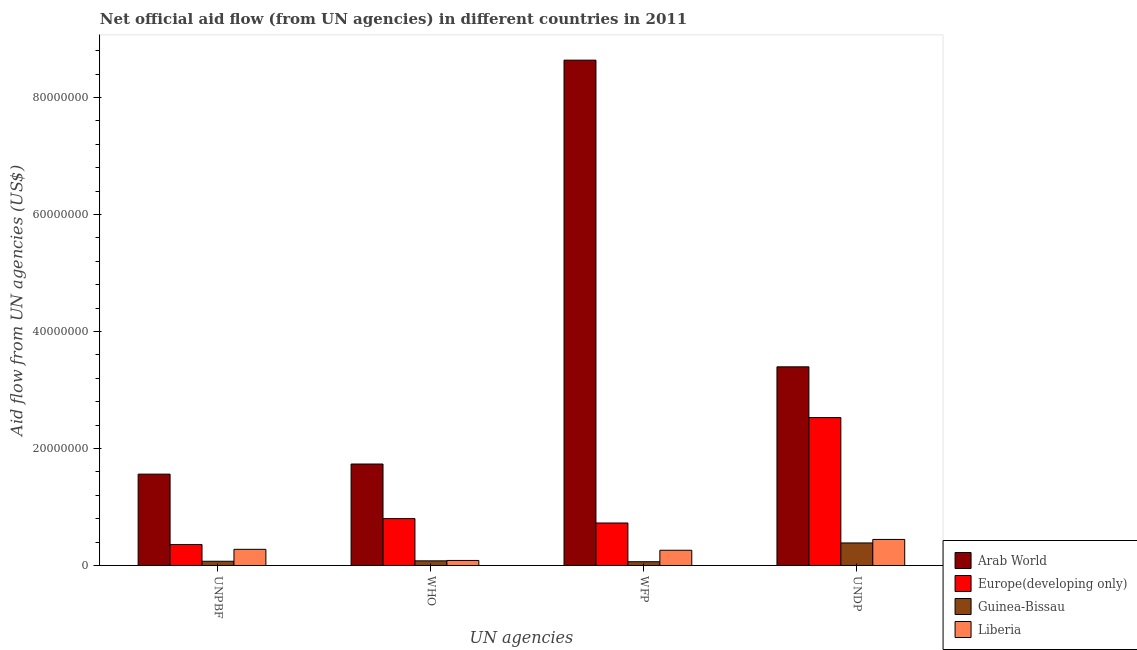How many bars are there on the 4th tick from the right?
Provide a short and direct response. 4. What is the label of the 1st group of bars from the left?
Keep it short and to the point. UNPBF. What is the amount of aid given by unpbf in Guinea-Bissau?
Your response must be concise. 7.20e+05. Across all countries, what is the maximum amount of aid given by who?
Your response must be concise. 1.73e+07. Across all countries, what is the minimum amount of aid given by unpbf?
Keep it short and to the point. 7.20e+05. In which country was the amount of aid given by undp maximum?
Your response must be concise. Arab World. In which country was the amount of aid given by undp minimum?
Provide a short and direct response. Guinea-Bissau. What is the total amount of aid given by undp in the graph?
Provide a succinct answer. 6.75e+07. What is the difference between the amount of aid given by undp in Liberia and that in Europe(developing only)?
Give a very brief answer. -2.08e+07. What is the difference between the amount of aid given by wfp in Europe(developing only) and the amount of aid given by who in Guinea-Bissau?
Your response must be concise. 6.47e+06. What is the average amount of aid given by unpbf per country?
Keep it short and to the point. 5.67e+06. What is the difference between the amount of aid given by wfp and amount of aid given by unpbf in Guinea-Bissau?
Provide a short and direct response. -8.00e+04. What is the ratio of the amount of aid given by undp in Liberia to that in Arab World?
Your answer should be compact. 0.13. What is the difference between the highest and the second highest amount of aid given by undp?
Give a very brief answer. 8.67e+06. What is the difference between the highest and the lowest amount of aid given by who?
Ensure brevity in your answer.  1.66e+07. Is it the case that in every country, the sum of the amount of aid given by unpbf and amount of aid given by who is greater than the sum of amount of aid given by wfp and amount of aid given by undp?
Offer a terse response. No. What does the 2nd bar from the left in UNDP represents?
Keep it short and to the point. Europe(developing only). What does the 4th bar from the right in UNPBF represents?
Your answer should be very brief. Arab World. Are all the bars in the graph horizontal?
Provide a short and direct response. No. How many countries are there in the graph?
Your answer should be very brief. 4. Are the values on the major ticks of Y-axis written in scientific E-notation?
Keep it short and to the point. No. Where does the legend appear in the graph?
Offer a very short reply. Bottom right. How are the legend labels stacked?
Keep it short and to the point. Vertical. What is the title of the graph?
Your answer should be compact. Net official aid flow (from UN agencies) in different countries in 2011. Does "Seychelles" appear as one of the legend labels in the graph?
Provide a succinct answer. No. What is the label or title of the X-axis?
Offer a very short reply. UN agencies. What is the label or title of the Y-axis?
Keep it short and to the point. Aid flow from UN agencies (US$). What is the Aid flow from UN agencies (US$) of Arab World in UNPBF?
Provide a short and direct response. 1.56e+07. What is the Aid flow from UN agencies (US$) of Europe(developing only) in UNPBF?
Provide a short and direct response. 3.58e+06. What is the Aid flow from UN agencies (US$) in Guinea-Bissau in UNPBF?
Give a very brief answer. 7.20e+05. What is the Aid flow from UN agencies (US$) in Liberia in UNPBF?
Offer a terse response. 2.76e+06. What is the Aid flow from UN agencies (US$) of Arab World in WHO?
Ensure brevity in your answer.  1.73e+07. What is the Aid flow from UN agencies (US$) of Europe(developing only) in WHO?
Offer a terse response. 8.01e+06. What is the Aid flow from UN agencies (US$) of Guinea-Bissau in WHO?
Offer a very short reply. 7.90e+05. What is the Aid flow from UN agencies (US$) of Liberia in WHO?
Provide a succinct answer. 8.60e+05. What is the Aid flow from UN agencies (US$) of Arab World in WFP?
Make the answer very short. 8.64e+07. What is the Aid flow from UN agencies (US$) in Europe(developing only) in WFP?
Ensure brevity in your answer.  7.26e+06. What is the Aid flow from UN agencies (US$) in Guinea-Bissau in WFP?
Make the answer very short. 6.40e+05. What is the Aid flow from UN agencies (US$) in Liberia in WFP?
Provide a succinct answer. 2.60e+06. What is the Aid flow from UN agencies (US$) of Arab World in UNDP?
Your answer should be compact. 3.40e+07. What is the Aid flow from UN agencies (US$) of Europe(developing only) in UNDP?
Provide a short and direct response. 2.53e+07. What is the Aid flow from UN agencies (US$) of Guinea-Bissau in UNDP?
Keep it short and to the point. 3.85e+06. What is the Aid flow from UN agencies (US$) in Liberia in UNDP?
Your response must be concise. 4.45e+06. Across all UN agencies, what is the maximum Aid flow from UN agencies (US$) of Arab World?
Provide a short and direct response. 8.64e+07. Across all UN agencies, what is the maximum Aid flow from UN agencies (US$) in Europe(developing only)?
Your answer should be very brief. 2.53e+07. Across all UN agencies, what is the maximum Aid flow from UN agencies (US$) in Guinea-Bissau?
Ensure brevity in your answer.  3.85e+06. Across all UN agencies, what is the maximum Aid flow from UN agencies (US$) in Liberia?
Give a very brief answer. 4.45e+06. Across all UN agencies, what is the minimum Aid flow from UN agencies (US$) in Arab World?
Your answer should be compact. 1.56e+07. Across all UN agencies, what is the minimum Aid flow from UN agencies (US$) in Europe(developing only)?
Keep it short and to the point. 3.58e+06. Across all UN agencies, what is the minimum Aid flow from UN agencies (US$) of Guinea-Bissau?
Your answer should be very brief. 6.40e+05. Across all UN agencies, what is the minimum Aid flow from UN agencies (US$) in Liberia?
Offer a terse response. 8.60e+05. What is the total Aid flow from UN agencies (US$) of Arab World in the graph?
Offer a terse response. 1.53e+08. What is the total Aid flow from UN agencies (US$) in Europe(developing only) in the graph?
Your answer should be very brief. 4.41e+07. What is the total Aid flow from UN agencies (US$) of Liberia in the graph?
Your response must be concise. 1.07e+07. What is the difference between the Aid flow from UN agencies (US$) of Arab World in UNPBF and that in WHO?
Give a very brief answer. -1.73e+06. What is the difference between the Aid flow from UN agencies (US$) in Europe(developing only) in UNPBF and that in WHO?
Your answer should be compact. -4.43e+06. What is the difference between the Aid flow from UN agencies (US$) of Guinea-Bissau in UNPBF and that in WHO?
Offer a terse response. -7.00e+04. What is the difference between the Aid flow from UN agencies (US$) of Liberia in UNPBF and that in WHO?
Give a very brief answer. 1.90e+06. What is the difference between the Aid flow from UN agencies (US$) in Arab World in UNPBF and that in WFP?
Provide a short and direct response. -7.08e+07. What is the difference between the Aid flow from UN agencies (US$) of Europe(developing only) in UNPBF and that in WFP?
Keep it short and to the point. -3.68e+06. What is the difference between the Aid flow from UN agencies (US$) in Guinea-Bissau in UNPBF and that in WFP?
Offer a very short reply. 8.00e+04. What is the difference between the Aid flow from UN agencies (US$) of Arab World in UNPBF and that in UNDP?
Provide a succinct answer. -1.83e+07. What is the difference between the Aid flow from UN agencies (US$) of Europe(developing only) in UNPBF and that in UNDP?
Keep it short and to the point. -2.17e+07. What is the difference between the Aid flow from UN agencies (US$) in Guinea-Bissau in UNPBF and that in UNDP?
Offer a terse response. -3.13e+06. What is the difference between the Aid flow from UN agencies (US$) in Liberia in UNPBF and that in UNDP?
Your answer should be very brief. -1.69e+06. What is the difference between the Aid flow from UN agencies (US$) in Arab World in WHO and that in WFP?
Offer a very short reply. -6.90e+07. What is the difference between the Aid flow from UN agencies (US$) of Europe(developing only) in WHO and that in WFP?
Provide a short and direct response. 7.50e+05. What is the difference between the Aid flow from UN agencies (US$) in Guinea-Bissau in WHO and that in WFP?
Provide a succinct answer. 1.50e+05. What is the difference between the Aid flow from UN agencies (US$) of Liberia in WHO and that in WFP?
Keep it short and to the point. -1.74e+06. What is the difference between the Aid flow from UN agencies (US$) in Arab World in WHO and that in UNDP?
Provide a short and direct response. -1.66e+07. What is the difference between the Aid flow from UN agencies (US$) in Europe(developing only) in WHO and that in UNDP?
Your response must be concise. -1.73e+07. What is the difference between the Aid flow from UN agencies (US$) in Guinea-Bissau in WHO and that in UNDP?
Your answer should be compact. -3.06e+06. What is the difference between the Aid flow from UN agencies (US$) in Liberia in WHO and that in UNDP?
Your answer should be compact. -3.59e+06. What is the difference between the Aid flow from UN agencies (US$) in Arab World in WFP and that in UNDP?
Your answer should be very brief. 5.24e+07. What is the difference between the Aid flow from UN agencies (US$) of Europe(developing only) in WFP and that in UNDP?
Your response must be concise. -1.80e+07. What is the difference between the Aid flow from UN agencies (US$) in Guinea-Bissau in WFP and that in UNDP?
Provide a succinct answer. -3.21e+06. What is the difference between the Aid flow from UN agencies (US$) of Liberia in WFP and that in UNDP?
Give a very brief answer. -1.85e+06. What is the difference between the Aid flow from UN agencies (US$) in Arab World in UNPBF and the Aid flow from UN agencies (US$) in Europe(developing only) in WHO?
Ensure brevity in your answer.  7.60e+06. What is the difference between the Aid flow from UN agencies (US$) in Arab World in UNPBF and the Aid flow from UN agencies (US$) in Guinea-Bissau in WHO?
Your answer should be compact. 1.48e+07. What is the difference between the Aid flow from UN agencies (US$) in Arab World in UNPBF and the Aid flow from UN agencies (US$) in Liberia in WHO?
Provide a short and direct response. 1.48e+07. What is the difference between the Aid flow from UN agencies (US$) in Europe(developing only) in UNPBF and the Aid flow from UN agencies (US$) in Guinea-Bissau in WHO?
Give a very brief answer. 2.79e+06. What is the difference between the Aid flow from UN agencies (US$) in Europe(developing only) in UNPBF and the Aid flow from UN agencies (US$) in Liberia in WHO?
Your answer should be very brief. 2.72e+06. What is the difference between the Aid flow from UN agencies (US$) in Guinea-Bissau in UNPBF and the Aid flow from UN agencies (US$) in Liberia in WHO?
Ensure brevity in your answer.  -1.40e+05. What is the difference between the Aid flow from UN agencies (US$) in Arab World in UNPBF and the Aid flow from UN agencies (US$) in Europe(developing only) in WFP?
Provide a succinct answer. 8.35e+06. What is the difference between the Aid flow from UN agencies (US$) in Arab World in UNPBF and the Aid flow from UN agencies (US$) in Guinea-Bissau in WFP?
Your answer should be very brief. 1.50e+07. What is the difference between the Aid flow from UN agencies (US$) in Arab World in UNPBF and the Aid flow from UN agencies (US$) in Liberia in WFP?
Provide a short and direct response. 1.30e+07. What is the difference between the Aid flow from UN agencies (US$) of Europe(developing only) in UNPBF and the Aid flow from UN agencies (US$) of Guinea-Bissau in WFP?
Provide a succinct answer. 2.94e+06. What is the difference between the Aid flow from UN agencies (US$) of Europe(developing only) in UNPBF and the Aid flow from UN agencies (US$) of Liberia in WFP?
Give a very brief answer. 9.80e+05. What is the difference between the Aid flow from UN agencies (US$) of Guinea-Bissau in UNPBF and the Aid flow from UN agencies (US$) of Liberia in WFP?
Ensure brevity in your answer.  -1.88e+06. What is the difference between the Aid flow from UN agencies (US$) of Arab World in UNPBF and the Aid flow from UN agencies (US$) of Europe(developing only) in UNDP?
Provide a succinct answer. -9.67e+06. What is the difference between the Aid flow from UN agencies (US$) of Arab World in UNPBF and the Aid flow from UN agencies (US$) of Guinea-Bissau in UNDP?
Provide a succinct answer. 1.18e+07. What is the difference between the Aid flow from UN agencies (US$) in Arab World in UNPBF and the Aid flow from UN agencies (US$) in Liberia in UNDP?
Make the answer very short. 1.12e+07. What is the difference between the Aid flow from UN agencies (US$) in Europe(developing only) in UNPBF and the Aid flow from UN agencies (US$) in Liberia in UNDP?
Ensure brevity in your answer.  -8.70e+05. What is the difference between the Aid flow from UN agencies (US$) of Guinea-Bissau in UNPBF and the Aid flow from UN agencies (US$) of Liberia in UNDP?
Give a very brief answer. -3.73e+06. What is the difference between the Aid flow from UN agencies (US$) of Arab World in WHO and the Aid flow from UN agencies (US$) of Europe(developing only) in WFP?
Ensure brevity in your answer.  1.01e+07. What is the difference between the Aid flow from UN agencies (US$) in Arab World in WHO and the Aid flow from UN agencies (US$) in Guinea-Bissau in WFP?
Offer a very short reply. 1.67e+07. What is the difference between the Aid flow from UN agencies (US$) of Arab World in WHO and the Aid flow from UN agencies (US$) of Liberia in WFP?
Your answer should be compact. 1.47e+07. What is the difference between the Aid flow from UN agencies (US$) of Europe(developing only) in WHO and the Aid flow from UN agencies (US$) of Guinea-Bissau in WFP?
Offer a terse response. 7.37e+06. What is the difference between the Aid flow from UN agencies (US$) of Europe(developing only) in WHO and the Aid flow from UN agencies (US$) of Liberia in WFP?
Ensure brevity in your answer.  5.41e+06. What is the difference between the Aid flow from UN agencies (US$) in Guinea-Bissau in WHO and the Aid flow from UN agencies (US$) in Liberia in WFP?
Keep it short and to the point. -1.81e+06. What is the difference between the Aid flow from UN agencies (US$) in Arab World in WHO and the Aid flow from UN agencies (US$) in Europe(developing only) in UNDP?
Make the answer very short. -7.94e+06. What is the difference between the Aid flow from UN agencies (US$) in Arab World in WHO and the Aid flow from UN agencies (US$) in Guinea-Bissau in UNDP?
Offer a very short reply. 1.35e+07. What is the difference between the Aid flow from UN agencies (US$) of Arab World in WHO and the Aid flow from UN agencies (US$) of Liberia in UNDP?
Provide a short and direct response. 1.29e+07. What is the difference between the Aid flow from UN agencies (US$) of Europe(developing only) in WHO and the Aid flow from UN agencies (US$) of Guinea-Bissau in UNDP?
Give a very brief answer. 4.16e+06. What is the difference between the Aid flow from UN agencies (US$) of Europe(developing only) in WHO and the Aid flow from UN agencies (US$) of Liberia in UNDP?
Provide a succinct answer. 3.56e+06. What is the difference between the Aid flow from UN agencies (US$) of Guinea-Bissau in WHO and the Aid flow from UN agencies (US$) of Liberia in UNDP?
Offer a terse response. -3.66e+06. What is the difference between the Aid flow from UN agencies (US$) in Arab World in WFP and the Aid flow from UN agencies (US$) in Europe(developing only) in UNDP?
Your answer should be compact. 6.11e+07. What is the difference between the Aid flow from UN agencies (US$) of Arab World in WFP and the Aid flow from UN agencies (US$) of Guinea-Bissau in UNDP?
Your answer should be very brief. 8.25e+07. What is the difference between the Aid flow from UN agencies (US$) in Arab World in WFP and the Aid flow from UN agencies (US$) in Liberia in UNDP?
Offer a terse response. 8.19e+07. What is the difference between the Aid flow from UN agencies (US$) of Europe(developing only) in WFP and the Aid flow from UN agencies (US$) of Guinea-Bissau in UNDP?
Give a very brief answer. 3.41e+06. What is the difference between the Aid flow from UN agencies (US$) in Europe(developing only) in WFP and the Aid flow from UN agencies (US$) in Liberia in UNDP?
Keep it short and to the point. 2.81e+06. What is the difference between the Aid flow from UN agencies (US$) in Guinea-Bissau in WFP and the Aid flow from UN agencies (US$) in Liberia in UNDP?
Offer a very short reply. -3.81e+06. What is the average Aid flow from UN agencies (US$) in Arab World per UN agencies?
Offer a terse response. 3.83e+07. What is the average Aid flow from UN agencies (US$) of Europe(developing only) per UN agencies?
Offer a terse response. 1.10e+07. What is the average Aid flow from UN agencies (US$) in Guinea-Bissau per UN agencies?
Provide a succinct answer. 1.50e+06. What is the average Aid flow from UN agencies (US$) in Liberia per UN agencies?
Ensure brevity in your answer.  2.67e+06. What is the difference between the Aid flow from UN agencies (US$) of Arab World and Aid flow from UN agencies (US$) of Europe(developing only) in UNPBF?
Your response must be concise. 1.20e+07. What is the difference between the Aid flow from UN agencies (US$) of Arab World and Aid flow from UN agencies (US$) of Guinea-Bissau in UNPBF?
Ensure brevity in your answer.  1.49e+07. What is the difference between the Aid flow from UN agencies (US$) of Arab World and Aid flow from UN agencies (US$) of Liberia in UNPBF?
Give a very brief answer. 1.28e+07. What is the difference between the Aid flow from UN agencies (US$) of Europe(developing only) and Aid flow from UN agencies (US$) of Guinea-Bissau in UNPBF?
Provide a short and direct response. 2.86e+06. What is the difference between the Aid flow from UN agencies (US$) in Europe(developing only) and Aid flow from UN agencies (US$) in Liberia in UNPBF?
Make the answer very short. 8.20e+05. What is the difference between the Aid flow from UN agencies (US$) of Guinea-Bissau and Aid flow from UN agencies (US$) of Liberia in UNPBF?
Offer a terse response. -2.04e+06. What is the difference between the Aid flow from UN agencies (US$) in Arab World and Aid flow from UN agencies (US$) in Europe(developing only) in WHO?
Offer a very short reply. 9.33e+06. What is the difference between the Aid flow from UN agencies (US$) of Arab World and Aid flow from UN agencies (US$) of Guinea-Bissau in WHO?
Give a very brief answer. 1.66e+07. What is the difference between the Aid flow from UN agencies (US$) in Arab World and Aid flow from UN agencies (US$) in Liberia in WHO?
Ensure brevity in your answer.  1.65e+07. What is the difference between the Aid flow from UN agencies (US$) in Europe(developing only) and Aid flow from UN agencies (US$) in Guinea-Bissau in WHO?
Provide a succinct answer. 7.22e+06. What is the difference between the Aid flow from UN agencies (US$) in Europe(developing only) and Aid flow from UN agencies (US$) in Liberia in WHO?
Make the answer very short. 7.15e+06. What is the difference between the Aid flow from UN agencies (US$) in Arab World and Aid flow from UN agencies (US$) in Europe(developing only) in WFP?
Provide a short and direct response. 7.91e+07. What is the difference between the Aid flow from UN agencies (US$) in Arab World and Aid flow from UN agencies (US$) in Guinea-Bissau in WFP?
Your answer should be very brief. 8.57e+07. What is the difference between the Aid flow from UN agencies (US$) of Arab World and Aid flow from UN agencies (US$) of Liberia in WFP?
Offer a terse response. 8.38e+07. What is the difference between the Aid flow from UN agencies (US$) in Europe(developing only) and Aid flow from UN agencies (US$) in Guinea-Bissau in WFP?
Provide a succinct answer. 6.62e+06. What is the difference between the Aid flow from UN agencies (US$) in Europe(developing only) and Aid flow from UN agencies (US$) in Liberia in WFP?
Offer a very short reply. 4.66e+06. What is the difference between the Aid flow from UN agencies (US$) in Guinea-Bissau and Aid flow from UN agencies (US$) in Liberia in WFP?
Offer a very short reply. -1.96e+06. What is the difference between the Aid flow from UN agencies (US$) of Arab World and Aid flow from UN agencies (US$) of Europe(developing only) in UNDP?
Make the answer very short. 8.67e+06. What is the difference between the Aid flow from UN agencies (US$) of Arab World and Aid flow from UN agencies (US$) of Guinea-Bissau in UNDP?
Provide a short and direct response. 3.01e+07. What is the difference between the Aid flow from UN agencies (US$) of Arab World and Aid flow from UN agencies (US$) of Liberia in UNDP?
Offer a terse response. 2.95e+07. What is the difference between the Aid flow from UN agencies (US$) in Europe(developing only) and Aid flow from UN agencies (US$) in Guinea-Bissau in UNDP?
Give a very brief answer. 2.14e+07. What is the difference between the Aid flow from UN agencies (US$) of Europe(developing only) and Aid flow from UN agencies (US$) of Liberia in UNDP?
Your answer should be compact. 2.08e+07. What is the difference between the Aid flow from UN agencies (US$) of Guinea-Bissau and Aid flow from UN agencies (US$) of Liberia in UNDP?
Provide a succinct answer. -6.00e+05. What is the ratio of the Aid flow from UN agencies (US$) of Arab World in UNPBF to that in WHO?
Keep it short and to the point. 0.9. What is the ratio of the Aid flow from UN agencies (US$) in Europe(developing only) in UNPBF to that in WHO?
Your answer should be very brief. 0.45. What is the ratio of the Aid flow from UN agencies (US$) in Guinea-Bissau in UNPBF to that in WHO?
Give a very brief answer. 0.91. What is the ratio of the Aid flow from UN agencies (US$) of Liberia in UNPBF to that in WHO?
Your response must be concise. 3.21. What is the ratio of the Aid flow from UN agencies (US$) in Arab World in UNPBF to that in WFP?
Offer a terse response. 0.18. What is the ratio of the Aid flow from UN agencies (US$) in Europe(developing only) in UNPBF to that in WFP?
Provide a short and direct response. 0.49. What is the ratio of the Aid flow from UN agencies (US$) of Guinea-Bissau in UNPBF to that in WFP?
Give a very brief answer. 1.12. What is the ratio of the Aid flow from UN agencies (US$) of Liberia in UNPBF to that in WFP?
Provide a succinct answer. 1.06. What is the ratio of the Aid flow from UN agencies (US$) in Arab World in UNPBF to that in UNDP?
Offer a terse response. 0.46. What is the ratio of the Aid flow from UN agencies (US$) in Europe(developing only) in UNPBF to that in UNDP?
Keep it short and to the point. 0.14. What is the ratio of the Aid flow from UN agencies (US$) of Guinea-Bissau in UNPBF to that in UNDP?
Give a very brief answer. 0.19. What is the ratio of the Aid flow from UN agencies (US$) in Liberia in UNPBF to that in UNDP?
Keep it short and to the point. 0.62. What is the ratio of the Aid flow from UN agencies (US$) of Arab World in WHO to that in WFP?
Offer a very short reply. 0.2. What is the ratio of the Aid flow from UN agencies (US$) in Europe(developing only) in WHO to that in WFP?
Make the answer very short. 1.1. What is the ratio of the Aid flow from UN agencies (US$) in Guinea-Bissau in WHO to that in WFP?
Offer a terse response. 1.23. What is the ratio of the Aid flow from UN agencies (US$) in Liberia in WHO to that in WFP?
Offer a terse response. 0.33. What is the ratio of the Aid flow from UN agencies (US$) in Arab World in WHO to that in UNDP?
Provide a succinct answer. 0.51. What is the ratio of the Aid flow from UN agencies (US$) in Europe(developing only) in WHO to that in UNDP?
Provide a succinct answer. 0.32. What is the ratio of the Aid flow from UN agencies (US$) of Guinea-Bissau in WHO to that in UNDP?
Your response must be concise. 0.21. What is the ratio of the Aid flow from UN agencies (US$) of Liberia in WHO to that in UNDP?
Your answer should be compact. 0.19. What is the ratio of the Aid flow from UN agencies (US$) of Arab World in WFP to that in UNDP?
Offer a terse response. 2.54. What is the ratio of the Aid flow from UN agencies (US$) in Europe(developing only) in WFP to that in UNDP?
Provide a short and direct response. 0.29. What is the ratio of the Aid flow from UN agencies (US$) of Guinea-Bissau in WFP to that in UNDP?
Your response must be concise. 0.17. What is the ratio of the Aid flow from UN agencies (US$) in Liberia in WFP to that in UNDP?
Your response must be concise. 0.58. What is the difference between the highest and the second highest Aid flow from UN agencies (US$) in Arab World?
Provide a short and direct response. 5.24e+07. What is the difference between the highest and the second highest Aid flow from UN agencies (US$) of Europe(developing only)?
Provide a succinct answer. 1.73e+07. What is the difference between the highest and the second highest Aid flow from UN agencies (US$) in Guinea-Bissau?
Your response must be concise. 3.06e+06. What is the difference between the highest and the second highest Aid flow from UN agencies (US$) in Liberia?
Provide a succinct answer. 1.69e+06. What is the difference between the highest and the lowest Aid flow from UN agencies (US$) of Arab World?
Make the answer very short. 7.08e+07. What is the difference between the highest and the lowest Aid flow from UN agencies (US$) of Europe(developing only)?
Your answer should be very brief. 2.17e+07. What is the difference between the highest and the lowest Aid flow from UN agencies (US$) of Guinea-Bissau?
Provide a succinct answer. 3.21e+06. What is the difference between the highest and the lowest Aid flow from UN agencies (US$) in Liberia?
Ensure brevity in your answer.  3.59e+06. 